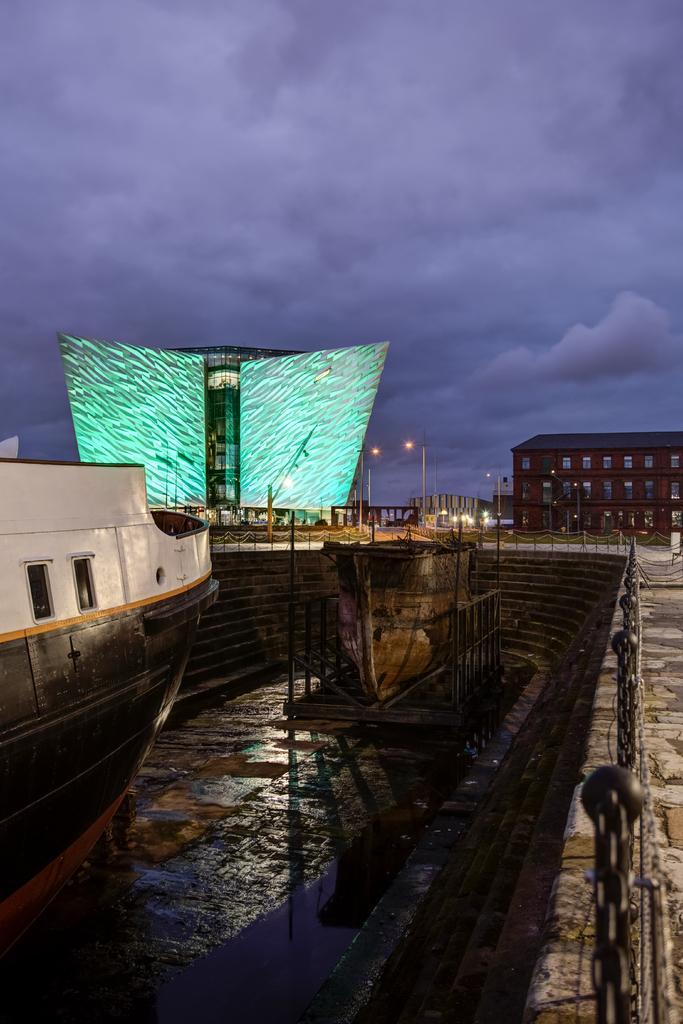In one or two sentences, can you explain what this image depicts? In this image we can see some boats placed on the surface. We can also see a staircase, poles with chains, a group of buildings, some street poles and the sky which looks cloudy. 